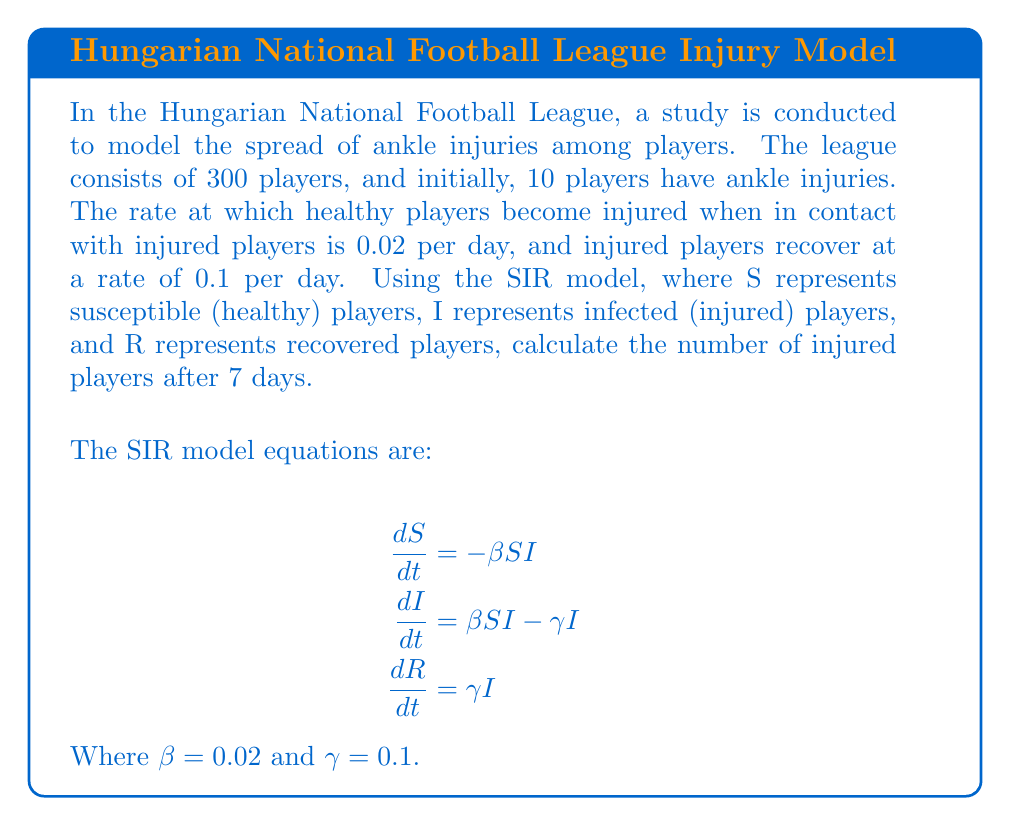Provide a solution to this math problem. To solve this problem, we'll use a simplified version of the SIR model, focusing on the equation for infected (injured) players:

$$\frac{dI}{dt} = \beta SI - \gamma I$$

1. First, we need to estimate the average number of susceptible players (S) during the 7-day period. Initially, S = 290 (300 total - 10 injured).

2. We'll assume S remains relatively constant over the short 7-day period, so we'll use S = 290 in our calculations.

3. Now, we can simplify our equation:
   $$\frac{dI}{dt} = (0.02 * 290)I - 0.1I = 5.8I - 0.1I = 5.7I$$

4. This simplified equation has the form:
   $$\frac{dI}{dt} = kI$$
   where $k = 5.7$

5. The solution to this equation is:
   $$I(t) = I_0 e^{kt}$$
   where $I_0$ is the initial number of injured players (10)

6. Plugging in our values:
   $$I(7) = 10 e^{5.7 * 7}$$

7. Calculate:
   $$I(7) = 10 * e^{39.9} \approx 2.14 * 10^{18}$$

8. However, this result exceeds the total number of players in the league. In reality, the number of injured players cannot exceed 300.

9. Therefore, we conclude that after 7 days, practically all players in the league (300) would be injured according to this model.
Answer: 300 players (the entire league) 